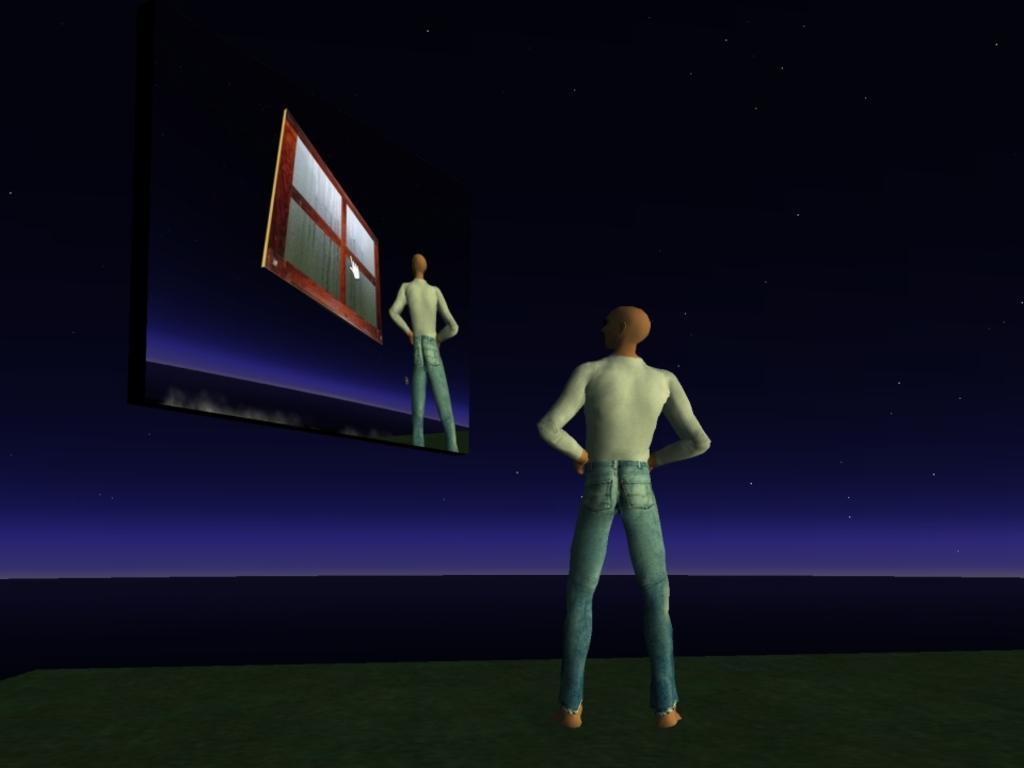Could you give a brief overview of what you see in this image? This is an animated image. In the image there is a man standing. And also there is a screen. On the screen there is a man and a window. There is a dark background with stars. 